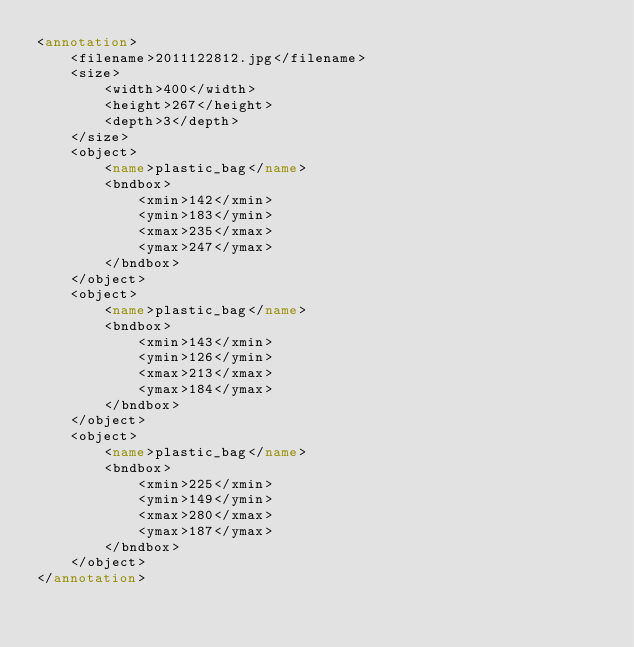<code> <loc_0><loc_0><loc_500><loc_500><_XML_><annotation>
	<filename>2011122812.jpg</filename>
	<size>
		<width>400</width>
		<height>267</height>
		<depth>3</depth>
	</size>
	<object>
		<name>plastic_bag</name>
		<bndbox>
			<xmin>142</xmin>
			<ymin>183</ymin>
			<xmax>235</xmax>
			<ymax>247</ymax>
		</bndbox>
	</object>
	<object>
		<name>plastic_bag</name>
		<bndbox>
			<xmin>143</xmin>
			<ymin>126</ymin>
			<xmax>213</xmax>
			<ymax>184</ymax>
		</bndbox>
	</object>
	<object>
		<name>plastic_bag</name>
		<bndbox>
			<xmin>225</xmin>
			<ymin>149</ymin>
			<xmax>280</xmax>
			<ymax>187</ymax>
		</bndbox>
	</object>
</annotation></code> 